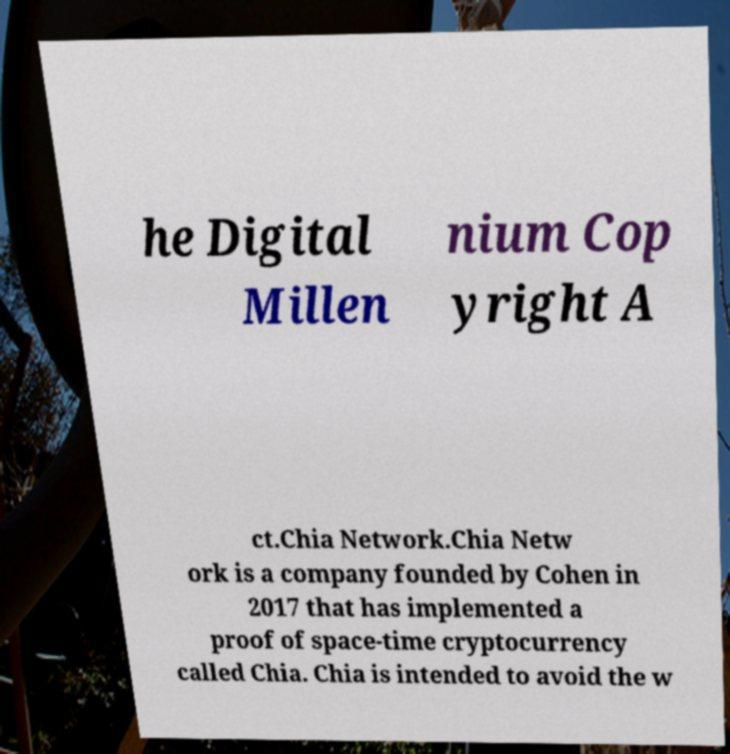What messages or text are displayed in this image? I need them in a readable, typed format. he Digital Millen nium Cop yright A ct.Chia Network.Chia Netw ork is a company founded by Cohen in 2017 that has implemented a proof of space-time cryptocurrency called Chia. Chia is intended to avoid the w 